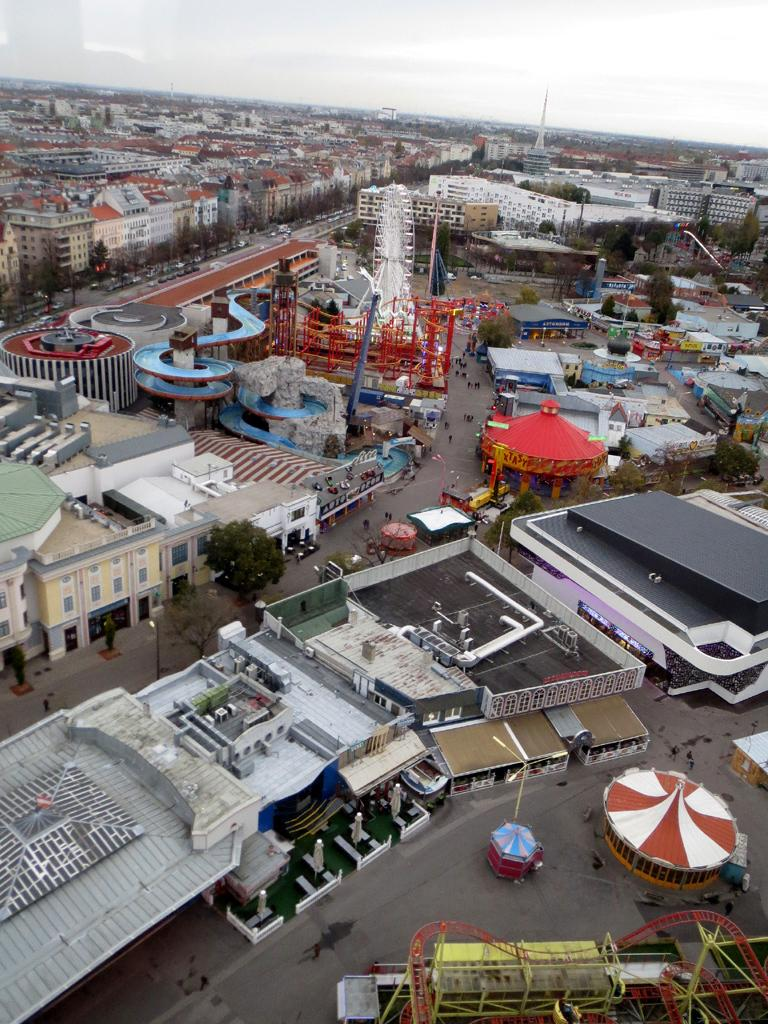What type of location is shown in the image? The image depicts a busy street. What can be seen in the background of the image? There are many buildings visible in the background. What are the people in the image doing? People are walking on the streets in the image. What mode of transportation can be seen on the roads? Cars are present on the roads in the image. What type of voice can be heard coming from the buildings in the image? There is no indication of any sound or voice in the image, as it only shows a visual representation of a busy street. 